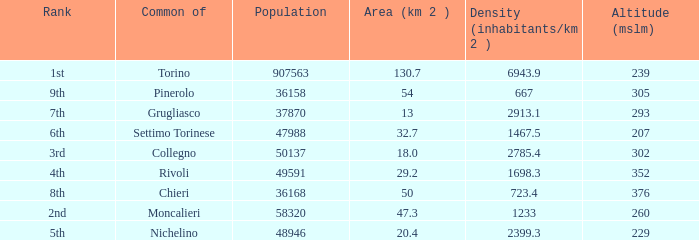What is the density of the common with an area of 20.4 km^2? 2399.3. 